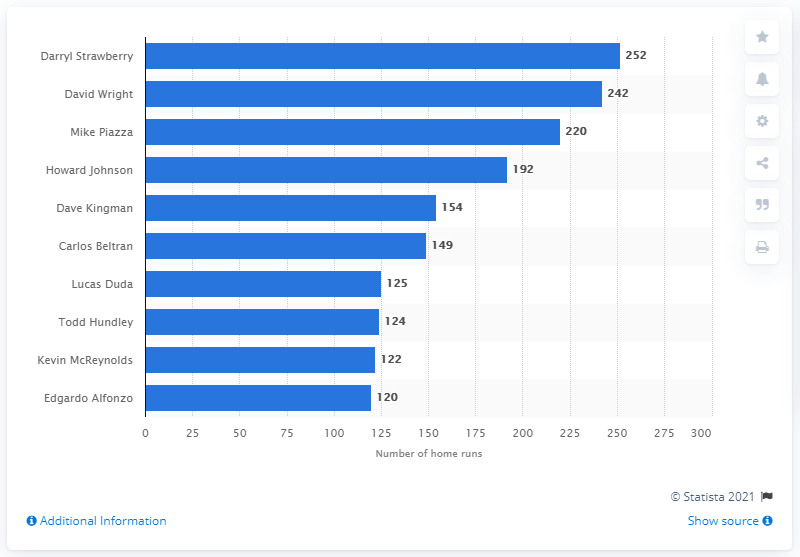Identify some key points in this picture. The New York Mets franchise record for most home runs is held by Darryl Strawberry, who has hit the most home runs in the team's history. The Mets top home run hitter has hit significantly more home runs than the second highest hitter, with a difference of 10 home runs. Darryl Strawberry is the all-time leading home run hitter for the Mets. I, Darryl Strawberry, have hit an impressive 252 home runs in my illustrious baseball career. 